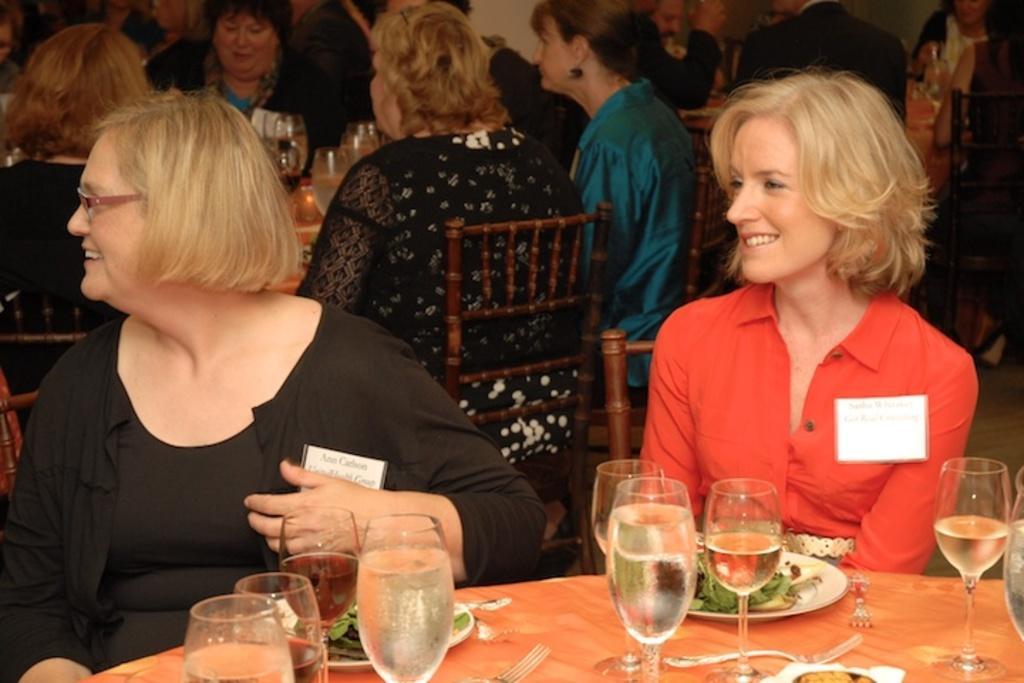Can you describe this image briefly? This picture describe that a inside view of the lunch party hall in which a group of women are sitting and enjoying the lunch, In Front table a woman wearing red shirt is sitting and smiling , beside there is another woman wearing black dress is smiling to, On the table we can see many water glasses, Food in the plates, spoons and forks. 